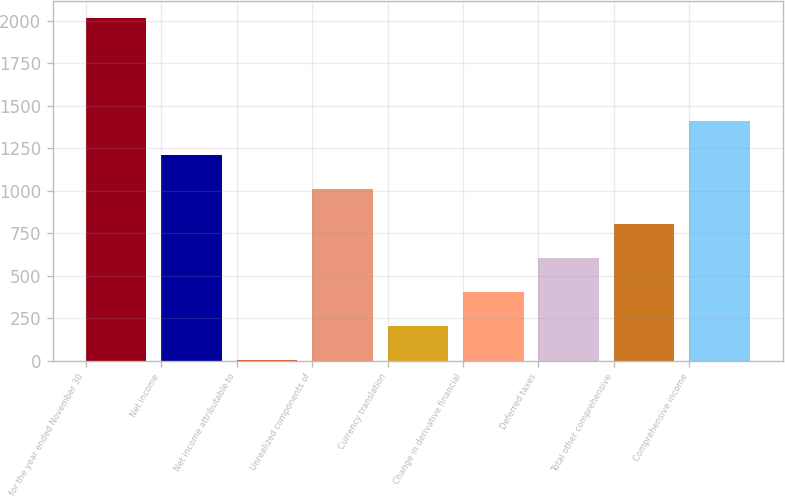Convert chart to OTSL. <chart><loc_0><loc_0><loc_500><loc_500><bar_chart><fcel>for the year ended November 30<fcel>Net income<fcel>Net income attributable to<fcel>Unrealized components of<fcel>Currency translation<fcel>Change in derivative financial<fcel>Deferred taxes<fcel>Total other comprehensive<fcel>Comprehensive income<nl><fcel>2013<fcel>1208.32<fcel>1.3<fcel>1007.15<fcel>202.47<fcel>403.64<fcel>604.81<fcel>805.98<fcel>1409.49<nl></chart> 